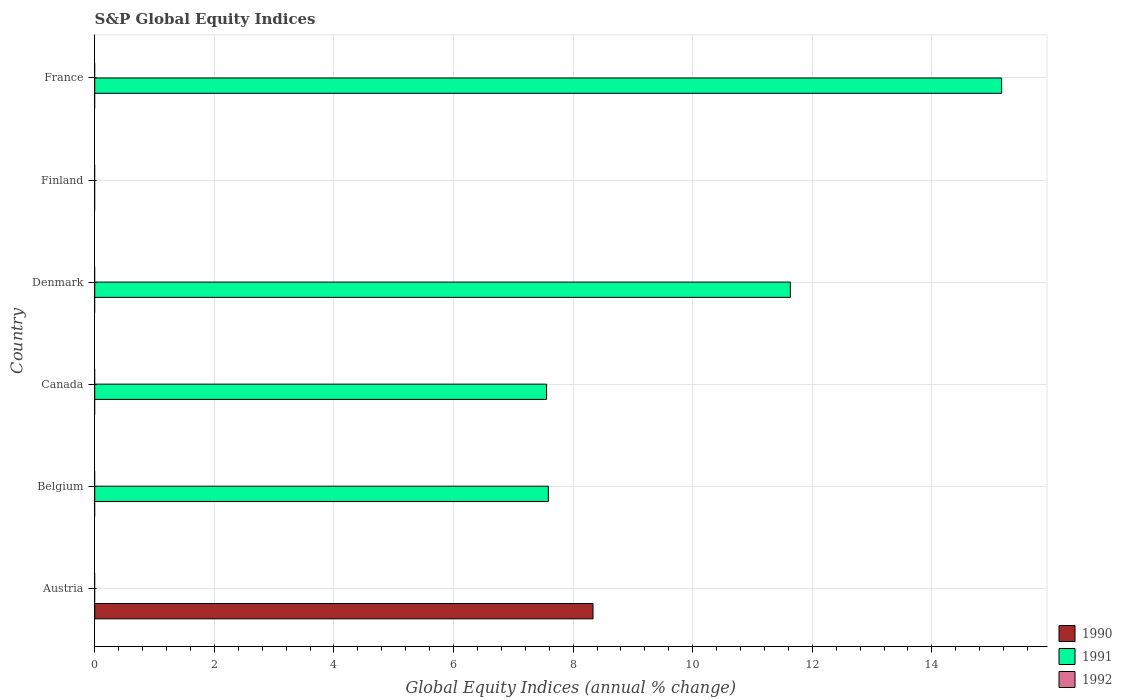In how many cases, is the number of bars for a given country not equal to the number of legend labels?
Offer a terse response. 6. Across all countries, what is the maximum global equity indices in 1990?
Ensure brevity in your answer.  8.33. In which country was the global equity indices in 1991 maximum?
Provide a short and direct response. France. What is the total global equity indices in 1990 in the graph?
Provide a short and direct response. 8.33. What is the difference between the global equity indices in 1991 in Canada and that in France?
Make the answer very short. -7.61. What is the difference between the global equity indices in 1990 in Denmark and the global equity indices in 1992 in France?
Provide a short and direct response. 0. What is the average global equity indices in 1992 per country?
Provide a succinct answer. 0. What is the ratio of the global equity indices in 1991 in Belgium to that in Denmark?
Your answer should be compact. 0.65. What is the difference between the highest and the second highest global equity indices in 1991?
Provide a short and direct response. 3.53. What is the difference between the highest and the lowest global equity indices in 1990?
Your response must be concise. 8.33. In how many countries, is the global equity indices in 1992 greater than the average global equity indices in 1992 taken over all countries?
Offer a terse response. 0. Is it the case that in every country, the sum of the global equity indices in 1990 and global equity indices in 1991 is greater than the global equity indices in 1992?
Keep it short and to the point. No. Are all the bars in the graph horizontal?
Give a very brief answer. Yes. Does the graph contain any zero values?
Provide a short and direct response. Yes. How many legend labels are there?
Offer a very short reply. 3. What is the title of the graph?
Provide a succinct answer. S&P Global Equity Indices. Does "2006" appear as one of the legend labels in the graph?
Ensure brevity in your answer.  No. What is the label or title of the X-axis?
Offer a terse response. Global Equity Indices (annual % change). What is the Global Equity Indices (annual % change) in 1990 in Austria?
Make the answer very short. 8.33. What is the Global Equity Indices (annual % change) of 1991 in Austria?
Offer a terse response. 0. What is the Global Equity Indices (annual % change) in 1992 in Austria?
Keep it short and to the point. 0. What is the Global Equity Indices (annual % change) in 1991 in Belgium?
Offer a very short reply. 7.59. What is the Global Equity Indices (annual % change) of 1990 in Canada?
Your answer should be very brief. 0. What is the Global Equity Indices (annual % change) of 1991 in Canada?
Keep it short and to the point. 7.56. What is the Global Equity Indices (annual % change) of 1992 in Canada?
Your answer should be very brief. 0. What is the Global Equity Indices (annual % change) in 1990 in Denmark?
Your answer should be very brief. 0. What is the Global Equity Indices (annual % change) in 1991 in Denmark?
Provide a succinct answer. 11.63. What is the Global Equity Indices (annual % change) of 1990 in Finland?
Provide a succinct answer. 0. What is the Global Equity Indices (annual % change) in 1992 in Finland?
Provide a short and direct response. 0. What is the Global Equity Indices (annual % change) in 1990 in France?
Keep it short and to the point. 0. What is the Global Equity Indices (annual % change) of 1991 in France?
Make the answer very short. 15.17. What is the Global Equity Indices (annual % change) in 1992 in France?
Give a very brief answer. 0. Across all countries, what is the maximum Global Equity Indices (annual % change) in 1990?
Provide a short and direct response. 8.33. Across all countries, what is the maximum Global Equity Indices (annual % change) of 1991?
Offer a terse response. 15.17. Across all countries, what is the minimum Global Equity Indices (annual % change) in 1990?
Offer a very short reply. 0. Across all countries, what is the minimum Global Equity Indices (annual % change) of 1991?
Offer a terse response. 0. What is the total Global Equity Indices (annual % change) in 1990 in the graph?
Provide a succinct answer. 8.33. What is the total Global Equity Indices (annual % change) in 1991 in the graph?
Offer a very short reply. 41.94. What is the total Global Equity Indices (annual % change) in 1992 in the graph?
Your answer should be compact. 0. What is the difference between the Global Equity Indices (annual % change) of 1991 in Belgium and that in Canada?
Give a very brief answer. 0.03. What is the difference between the Global Equity Indices (annual % change) in 1991 in Belgium and that in Denmark?
Offer a terse response. -4.05. What is the difference between the Global Equity Indices (annual % change) in 1991 in Belgium and that in France?
Your response must be concise. -7.58. What is the difference between the Global Equity Indices (annual % change) in 1991 in Canada and that in Denmark?
Provide a short and direct response. -4.08. What is the difference between the Global Equity Indices (annual % change) of 1991 in Canada and that in France?
Make the answer very short. -7.61. What is the difference between the Global Equity Indices (annual % change) in 1991 in Denmark and that in France?
Make the answer very short. -3.53. What is the difference between the Global Equity Indices (annual % change) in 1990 in Austria and the Global Equity Indices (annual % change) in 1991 in Belgium?
Give a very brief answer. 0.75. What is the difference between the Global Equity Indices (annual % change) of 1990 in Austria and the Global Equity Indices (annual % change) of 1991 in Canada?
Make the answer very short. 0.78. What is the difference between the Global Equity Indices (annual % change) in 1990 in Austria and the Global Equity Indices (annual % change) in 1991 in Denmark?
Your answer should be compact. -3.3. What is the difference between the Global Equity Indices (annual % change) of 1990 in Austria and the Global Equity Indices (annual % change) of 1991 in France?
Keep it short and to the point. -6.83. What is the average Global Equity Indices (annual % change) in 1990 per country?
Provide a short and direct response. 1.39. What is the average Global Equity Indices (annual % change) of 1991 per country?
Keep it short and to the point. 6.99. What is the ratio of the Global Equity Indices (annual % change) in 1991 in Belgium to that in Denmark?
Provide a short and direct response. 0.65. What is the ratio of the Global Equity Indices (annual % change) of 1991 in Belgium to that in France?
Offer a very short reply. 0.5. What is the ratio of the Global Equity Indices (annual % change) of 1991 in Canada to that in Denmark?
Ensure brevity in your answer.  0.65. What is the ratio of the Global Equity Indices (annual % change) in 1991 in Canada to that in France?
Your answer should be very brief. 0.5. What is the ratio of the Global Equity Indices (annual % change) in 1991 in Denmark to that in France?
Your answer should be very brief. 0.77. What is the difference between the highest and the second highest Global Equity Indices (annual % change) of 1991?
Your answer should be compact. 3.53. What is the difference between the highest and the lowest Global Equity Indices (annual % change) of 1990?
Provide a succinct answer. 8.33. What is the difference between the highest and the lowest Global Equity Indices (annual % change) of 1991?
Offer a very short reply. 15.17. 